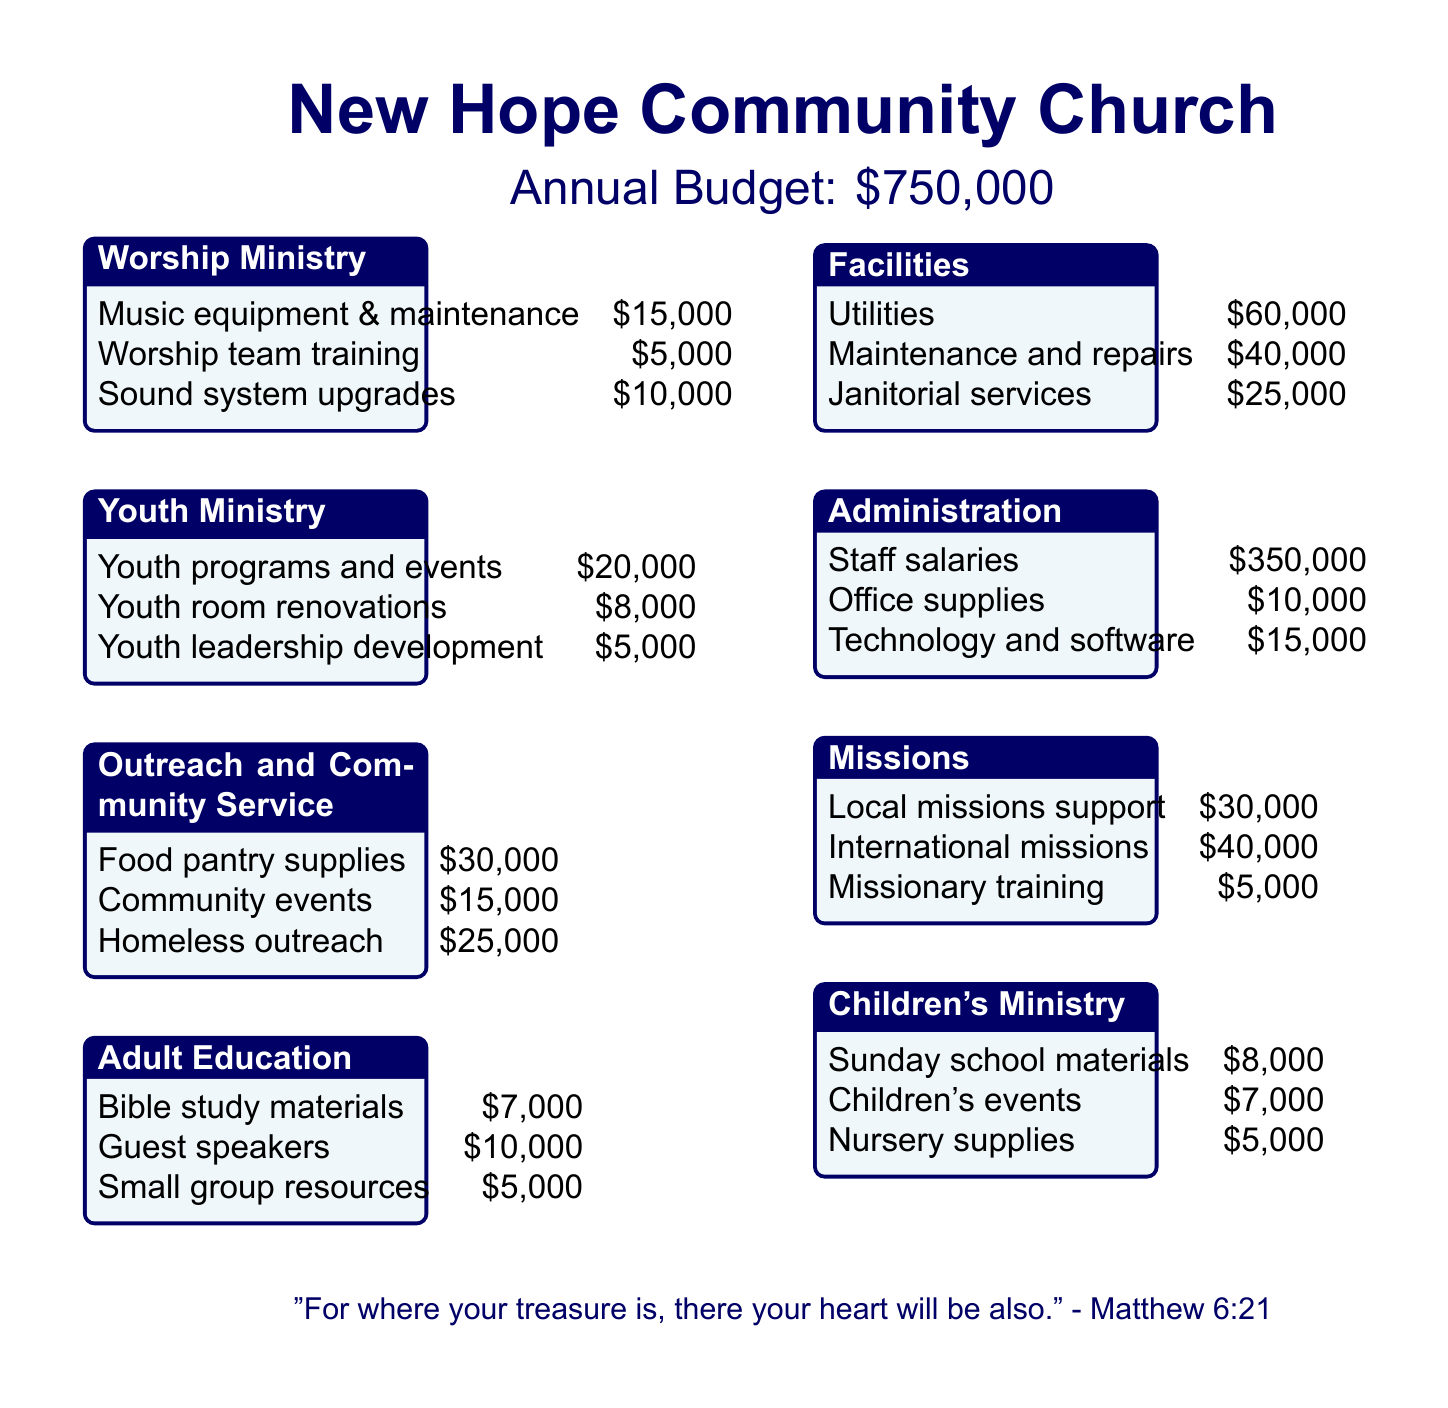what is the total budget for the church? The total budget is stated at the beginning of the document as $750,000.
Answer: $750,000 how much is allocated for Adult Education? The Adult Education section lists Bible study materials, guest speakers, and small group resources totaling $22,000.
Answer: $22,000 what is the budget for Youth programs and events? It is specifically listed under Youth Ministry as $20,000.
Answer: $20,000 which ministry has the highest allocation? The Administration ministry has the highest allocation with staff salaries of $350,000.
Answer: Administration how much is spent on utility costs? The Facilities section indicates utility costs amount to $60,000.
Answer: $60,000 what is the total allocated for Outreach and Community Service? The total allocation for Outreach and Community Service is the sum of three listed items: $30,000 + $15,000 + $25,000 = $70,000.
Answer: $70,000 how many categories are detailed in the document? There are seven ministries detailed in the document.
Answer: seven what is the combined budget for the Worship Ministry? The combined budget for Worship Ministry includes music equipment, training, and upgrades totaling $30,000.
Answer: $30,000 what is the expense for nursery supplies under Children's Ministry? Nursery supplies are specified as costing $5,000 under Children's Ministry.
Answer: $5,000 